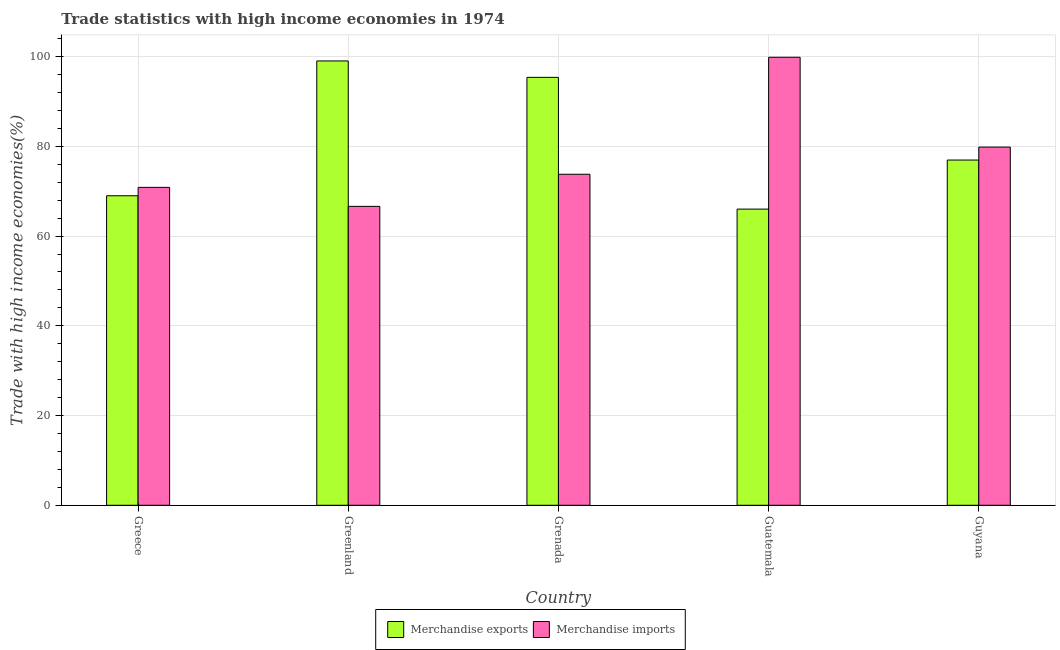How many groups of bars are there?
Keep it short and to the point. 5. How many bars are there on the 5th tick from the left?
Your answer should be very brief. 2. What is the label of the 4th group of bars from the left?
Your answer should be very brief. Guatemala. In how many cases, is the number of bars for a given country not equal to the number of legend labels?
Give a very brief answer. 0. What is the merchandise imports in Greece?
Keep it short and to the point. 70.86. Across all countries, what is the maximum merchandise imports?
Give a very brief answer. 99.86. Across all countries, what is the minimum merchandise exports?
Your answer should be very brief. 66.02. In which country was the merchandise exports maximum?
Give a very brief answer. Greenland. In which country was the merchandise exports minimum?
Ensure brevity in your answer.  Guatemala. What is the total merchandise imports in the graph?
Offer a terse response. 390.97. What is the difference between the merchandise imports in Greece and that in Grenada?
Ensure brevity in your answer.  -2.92. What is the difference between the merchandise imports in Guatemala and the merchandise exports in Greece?
Provide a succinct answer. 30.87. What is the average merchandise imports per country?
Your answer should be compact. 78.19. What is the difference between the merchandise imports and merchandise exports in Guatemala?
Keep it short and to the point. 33.84. What is the ratio of the merchandise imports in Greece to that in Guyana?
Your answer should be very brief. 0.89. Is the merchandise imports in Greece less than that in Grenada?
Your answer should be compact. Yes. Is the difference between the merchandise exports in Grenada and Guatemala greater than the difference between the merchandise imports in Grenada and Guatemala?
Provide a short and direct response. Yes. What is the difference between the highest and the second highest merchandise imports?
Offer a terse response. 20.02. What is the difference between the highest and the lowest merchandise exports?
Make the answer very short. 33.02. Is the sum of the merchandise imports in Grenada and Guyana greater than the maximum merchandise exports across all countries?
Your response must be concise. Yes. What does the 1st bar from the left in Greece represents?
Your answer should be very brief. Merchandise exports. What does the 2nd bar from the right in Greenland represents?
Provide a short and direct response. Merchandise exports. How many bars are there?
Give a very brief answer. 10. What is the difference between two consecutive major ticks on the Y-axis?
Provide a short and direct response. 20. Are the values on the major ticks of Y-axis written in scientific E-notation?
Your response must be concise. No. Does the graph contain any zero values?
Provide a succinct answer. No. Does the graph contain grids?
Your answer should be compact. Yes. How many legend labels are there?
Offer a terse response. 2. How are the legend labels stacked?
Provide a succinct answer. Horizontal. What is the title of the graph?
Make the answer very short. Trade statistics with high income economies in 1974. Does "Female labor force" appear as one of the legend labels in the graph?
Give a very brief answer. No. What is the label or title of the Y-axis?
Provide a short and direct response. Trade with high income economies(%). What is the Trade with high income economies(%) of Merchandise exports in Greece?
Keep it short and to the point. 68.99. What is the Trade with high income economies(%) in Merchandise imports in Greece?
Your response must be concise. 70.86. What is the Trade with high income economies(%) of Merchandise exports in Greenland?
Offer a terse response. 99.04. What is the Trade with high income economies(%) of Merchandise imports in Greenland?
Your response must be concise. 66.63. What is the Trade with high income economies(%) of Merchandise exports in Grenada?
Offer a very short reply. 95.38. What is the Trade with high income economies(%) in Merchandise imports in Grenada?
Offer a very short reply. 73.78. What is the Trade with high income economies(%) in Merchandise exports in Guatemala?
Make the answer very short. 66.02. What is the Trade with high income economies(%) in Merchandise imports in Guatemala?
Your answer should be compact. 99.86. What is the Trade with high income economies(%) in Merchandise exports in Guyana?
Give a very brief answer. 76.95. What is the Trade with high income economies(%) in Merchandise imports in Guyana?
Provide a short and direct response. 79.84. Across all countries, what is the maximum Trade with high income economies(%) in Merchandise exports?
Ensure brevity in your answer.  99.04. Across all countries, what is the maximum Trade with high income economies(%) of Merchandise imports?
Your answer should be compact. 99.86. Across all countries, what is the minimum Trade with high income economies(%) in Merchandise exports?
Your answer should be compact. 66.02. Across all countries, what is the minimum Trade with high income economies(%) in Merchandise imports?
Provide a short and direct response. 66.63. What is the total Trade with high income economies(%) in Merchandise exports in the graph?
Make the answer very short. 406.38. What is the total Trade with high income economies(%) of Merchandise imports in the graph?
Make the answer very short. 390.97. What is the difference between the Trade with high income economies(%) of Merchandise exports in Greece and that in Greenland?
Give a very brief answer. -30.05. What is the difference between the Trade with high income economies(%) of Merchandise imports in Greece and that in Greenland?
Make the answer very short. 4.24. What is the difference between the Trade with high income economies(%) in Merchandise exports in Greece and that in Grenada?
Ensure brevity in your answer.  -26.39. What is the difference between the Trade with high income economies(%) in Merchandise imports in Greece and that in Grenada?
Your answer should be compact. -2.92. What is the difference between the Trade with high income economies(%) of Merchandise exports in Greece and that in Guatemala?
Give a very brief answer. 2.97. What is the difference between the Trade with high income economies(%) in Merchandise imports in Greece and that in Guatemala?
Make the answer very short. -29. What is the difference between the Trade with high income economies(%) in Merchandise exports in Greece and that in Guyana?
Give a very brief answer. -7.96. What is the difference between the Trade with high income economies(%) in Merchandise imports in Greece and that in Guyana?
Your response must be concise. -8.98. What is the difference between the Trade with high income economies(%) of Merchandise exports in Greenland and that in Grenada?
Make the answer very short. 3.66. What is the difference between the Trade with high income economies(%) of Merchandise imports in Greenland and that in Grenada?
Your response must be concise. -7.16. What is the difference between the Trade with high income economies(%) in Merchandise exports in Greenland and that in Guatemala?
Offer a very short reply. 33.02. What is the difference between the Trade with high income economies(%) of Merchandise imports in Greenland and that in Guatemala?
Make the answer very short. -33.23. What is the difference between the Trade with high income economies(%) in Merchandise exports in Greenland and that in Guyana?
Offer a terse response. 22.09. What is the difference between the Trade with high income economies(%) of Merchandise imports in Greenland and that in Guyana?
Keep it short and to the point. -13.21. What is the difference between the Trade with high income economies(%) in Merchandise exports in Grenada and that in Guatemala?
Your answer should be very brief. 29.36. What is the difference between the Trade with high income economies(%) of Merchandise imports in Grenada and that in Guatemala?
Offer a very short reply. -26.07. What is the difference between the Trade with high income economies(%) of Merchandise exports in Grenada and that in Guyana?
Your response must be concise. 18.43. What is the difference between the Trade with high income economies(%) of Merchandise imports in Grenada and that in Guyana?
Provide a short and direct response. -6.06. What is the difference between the Trade with high income economies(%) of Merchandise exports in Guatemala and that in Guyana?
Offer a terse response. -10.93. What is the difference between the Trade with high income economies(%) in Merchandise imports in Guatemala and that in Guyana?
Ensure brevity in your answer.  20.02. What is the difference between the Trade with high income economies(%) in Merchandise exports in Greece and the Trade with high income economies(%) in Merchandise imports in Greenland?
Offer a terse response. 2.36. What is the difference between the Trade with high income economies(%) in Merchandise exports in Greece and the Trade with high income economies(%) in Merchandise imports in Grenada?
Keep it short and to the point. -4.79. What is the difference between the Trade with high income economies(%) of Merchandise exports in Greece and the Trade with high income economies(%) of Merchandise imports in Guatemala?
Offer a very short reply. -30.87. What is the difference between the Trade with high income economies(%) of Merchandise exports in Greece and the Trade with high income economies(%) of Merchandise imports in Guyana?
Your answer should be compact. -10.85. What is the difference between the Trade with high income economies(%) in Merchandise exports in Greenland and the Trade with high income economies(%) in Merchandise imports in Grenada?
Offer a terse response. 25.26. What is the difference between the Trade with high income economies(%) of Merchandise exports in Greenland and the Trade with high income economies(%) of Merchandise imports in Guatemala?
Your response must be concise. -0.82. What is the difference between the Trade with high income economies(%) in Merchandise exports in Greenland and the Trade with high income economies(%) in Merchandise imports in Guyana?
Ensure brevity in your answer.  19.2. What is the difference between the Trade with high income economies(%) in Merchandise exports in Grenada and the Trade with high income economies(%) in Merchandise imports in Guatemala?
Provide a short and direct response. -4.48. What is the difference between the Trade with high income economies(%) of Merchandise exports in Grenada and the Trade with high income economies(%) of Merchandise imports in Guyana?
Make the answer very short. 15.54. What is the difference between the Trade with high income economies(%) of Merchandise exports in Guatemala and the Trade with high income economies(%) of Merchandise imports in Guyana?
Provide a short and direct response. -13.82. What is the average Trade with high income economies(%) of Merchandise exports per country?
Your answer should be compact. 81.28. What is the average Trade with high income economies(%) of Merchandise imports per country?
Keep it short and to the point. 78.19. What is the difference between the Trade with high income economies(%) in Merchandise exports and Trade with high income economies(%) in Merchandise imports in Greece?
Provide a short and direct response. -1.87. What is the difference between the Trade with high income economies(%) of Merchandise exports and Trade with high income economies(%) of Merchandise imports in Greenland?
Keep it short and to the point. 32.42. What is the difference between the Trade with high income economies(%) in Merchandise exports and Trade with high income economies(%) in Merchandise imports in Grenada?
Offer a terse response. 21.6. What is the difference between the Trade with high income economies(%) in Merchandise exports and Trade with high income economies(%) in Merchandise imports in Guatemala?
Provide a succinct answer. -33.84. What is the difference between the Trade with high income economies(%) of Merchandise exports and Trade with high income economies(%) of Merchandise imports in Guyana?
Keep it short and to the point. -2.89. What is the ratio of the Trade with high income economies(%) in Merchandise exports in Greece to that in Greenland?
Give a very brief answer. 0.7. What is the ratio of the Trade with high income economies(%) of Merchandise imports in Greece to that in Greenland?
Ensure brevity in your answer.  1.06. What is the ratio of the Trade with high income economies(%) of Merchandise exports in Greece to that in Grenada?
Provide a succinct answer. 0.72. What is the ratio of the Trade with high income economies(%) of Merchandise imports in Greece to that in Grenada?
Give a very brief answer. 0.96. What is the ratio of the Trade with high income economies(%) in Merchandise exports in Greece to that in Guatemala?
Offer a terse response. 1.04. What is the ratio of the Trade with high income economies(%) of Merchandise imports in Greece to that in Guatemala?
Your response must be concise. 0.71. What is the ratio of the Trade with high income economies(%) in Merchandise exports in Greece to that in Guyana?
Ensure brevity in your answer.  0.9. What is the ratio of the Trade with high income economies(%) in Merchandise imports in Greece to that in Guyana?
Give a very brief answer. 0.89. What is the ratio of the Trade with high income economies(%) in Merchandise exports in Greenland to that in Grenada?
Ensure brevity in your answer.  1.04. What is the ratio of the Trade with high income economies(%) of Merchandise imports in Greenland to that in Grenada?
Give a very brief answer. 0.9. What is the ratio of the Trade with high income economies(%) of Merchandise exports in Greenland to that in Guatemala?
Make the answer very short. 1.5. What is the ratio of the Trade with high income economies(%) in Merchandise imports in Greenland to that in Guatemala?
Keep it short and to the point. 0.67. What is the ratio of the Trade with high income economies(%) in Merchandise exports in Greenland to that in Guyana?
Your answer should be very brief. 1.29. What is the ratio of the Trade with high income economies(%) of Merchandise imports in Greenland to that in Guyana?
Your response must be concise. 0.83. What is the ratio of the Trade with high income economies(%) of Merchandise exports in Grenada to that in Guatemala?
Provide a short and direct response. 1.44. What is the ratio of the Trade with high income economies(%) of Merchandise imports in Grenada to that in Guatemala?
Your answer should be compact. 0.74. What is the ratio of the Trade with high income economies(%) in Merchandise exports in Grenada to that in Guyana?
Keep it short and to the point. 1.24. What is the ratio of the Trade with high income economies(%) in Merchandise imports in Grenada to that in Guyana?
Your response must be concise. 0.92. What is the ratio of the Trade with high income economies(%) in Merchandise exports in Guatemala to that in Guyana?
Your response must be concise. 0.86. What is the ratio of the Trade with high income economies(%) in Merchandise imports in Guatemala to that in Guyana?
Your response must be concise. 1.25. What is the difference between the highest and the second highest Trade with high income economies(%) in Merchandise exports?
Make the answer very short. 3.66. What is the difference between the highest and the second highest Trade with high income economies(%) in Merchandise imports?
Offer a very short reply. 20.02. What is the difference between the highest and the lowest Trade with high income economies(%) in Merchandise exports?
Give a very brief answer. 33.02. What is the difference between the highest and the lowest Trade with high income economies(%) in Merchandise imports?
Offer a very short reply. 33.23. 